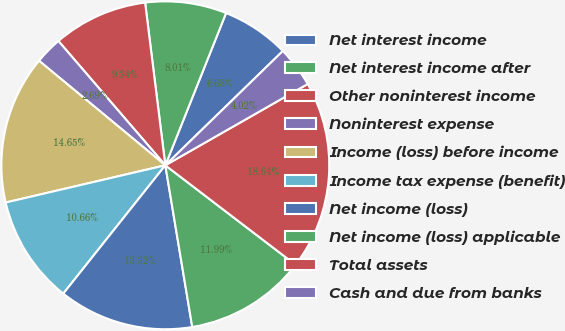<chart> <loc_0><loc_0><loc_500><loc_500><pie_chart><fcel>Net interest income<fcel>Net interest income after<fcel>Other noninterest income<fcel>Noninterest expense<fcel>Income (loss) before income<fcel>Income tax expense (benefit)<fcel>Net income (loss)<fcel>Net income (loss) applicable<fcel>Total assets<fcel>Cash and due from banks<nl><fcel>6.68%<fcel>8.01%<fcel>9.34%<fcel>2.69%<fcel>14.65%<fcel>10.66%<fcel>13.32%<fcel>11.99%<fcel>18.64%<fcel>4.02%<nl></chart> 